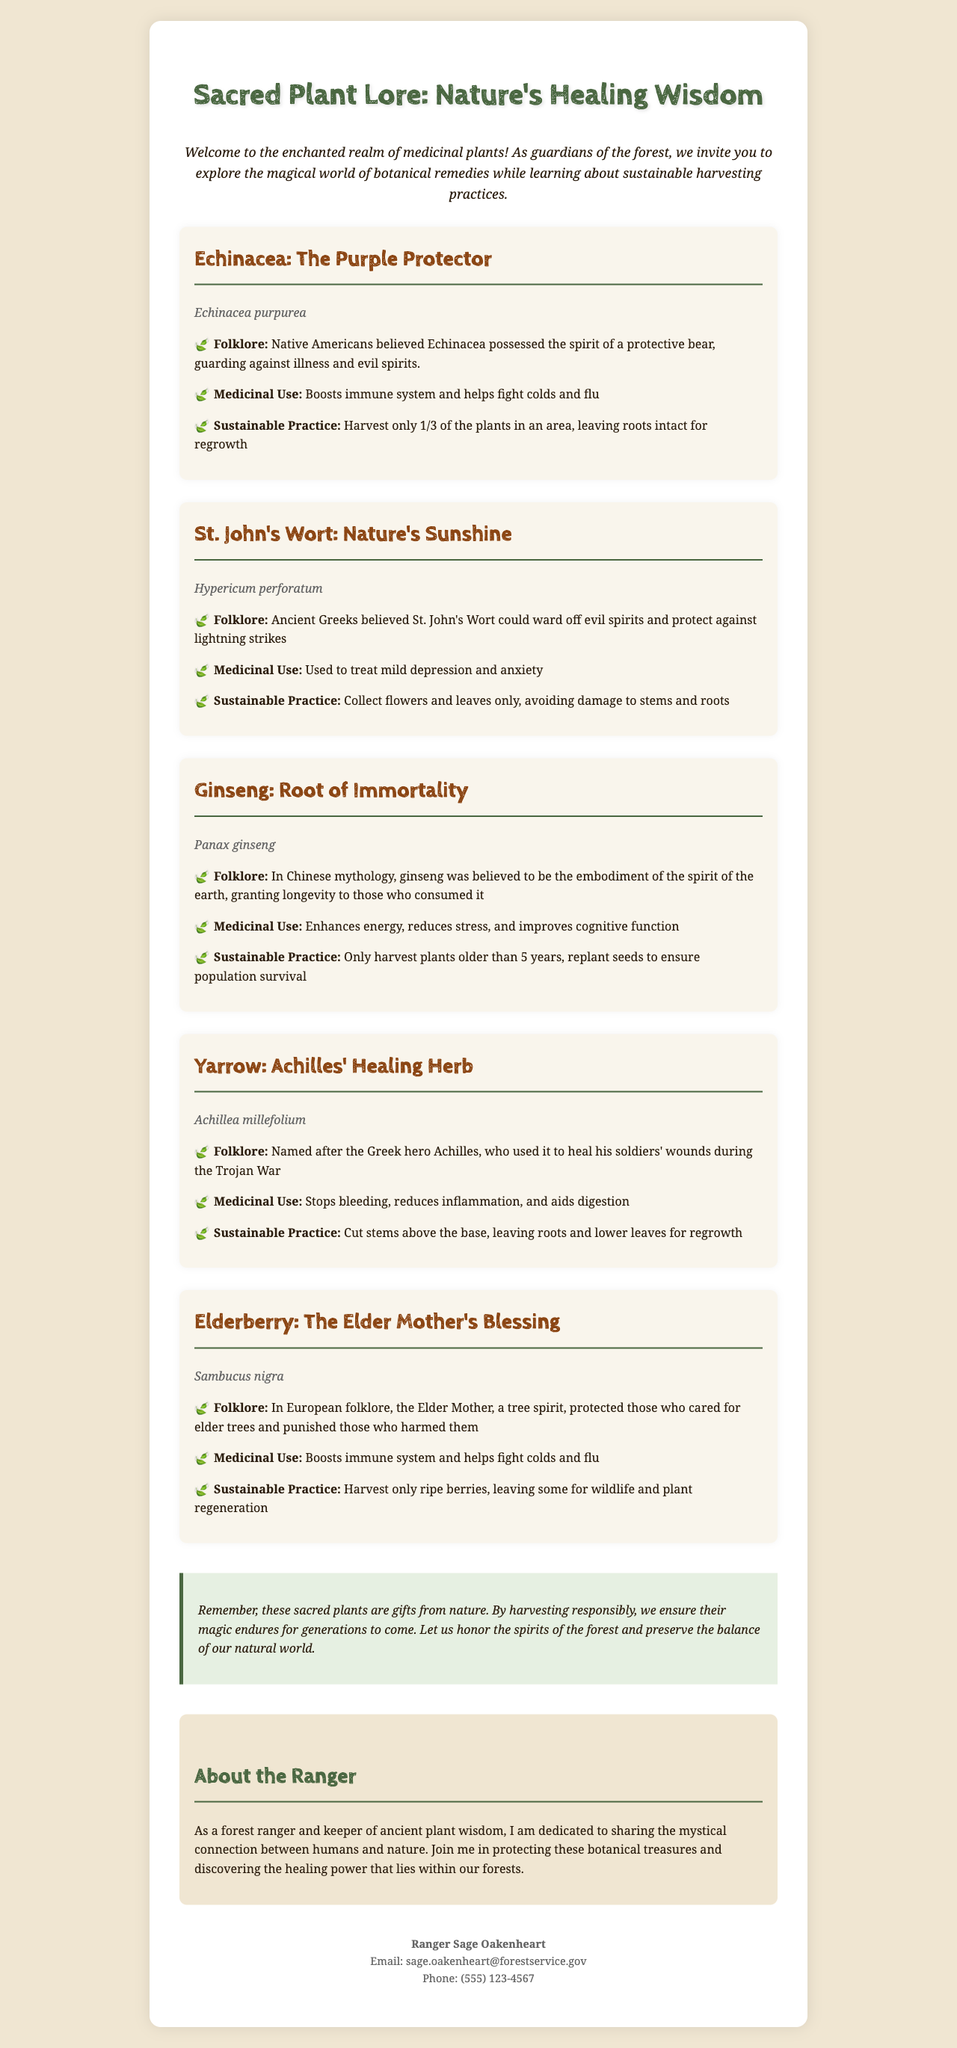What is the title of the brochure? The title of the brochure is stated at the top of the document.
Answer: Sacred Plant Lore: Nature's Healing Wisdom Who is the ranger featured in the brochure? The ranger is introduced in the "About the Ranger" section.
Answer: Ranger Sage Oakenheart What is Echinacea's scientific name? The scientific name is listed under each plant section.
Answer: Echinacea purpurea How many plants should be harvested in an area for Echinacea? The sustainable practice for Echinacea specifies the amount that should be harvested.
Answer: 1/3 What medicinal use is attributed to St. John's Wort? The medicinal uses are described in each plant section.
Answer: Treat mild depression and anxiety What folklore is associated with Ginseng? The folklore is shared in the respective section for Ginseng.
Answer: Embodiment of the spirit of the earth What should be harvested from Elderberry? The sustainable practice states what part of the plant should be harvested.
Answer: Ripe berries What message does the brochure convey regarding plant conservation? The conservation message emphasizes the importance of sustainable practices.
Answer: Harvesting responsibly Which plant is referred to as "Nature's Sunshine"? The title for St. John's Wort is mentioned prominently in its section.
Answer: St. John's Wort 